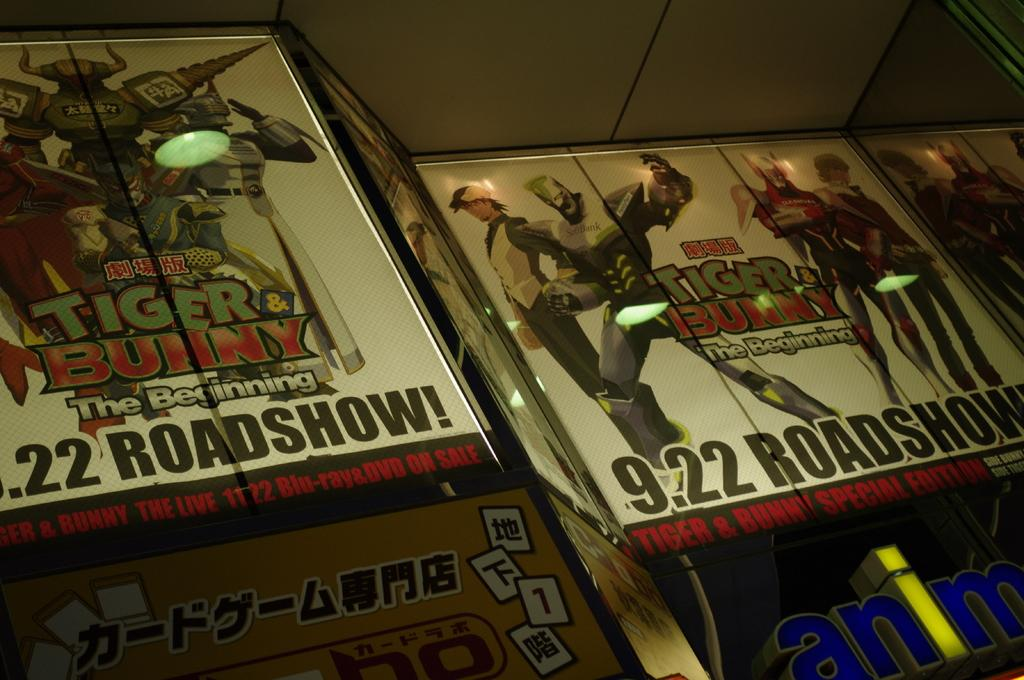<image>
Render a clear and concise summary of the photo. DVD covers to Tiger and Bunny Special Edition on display. 